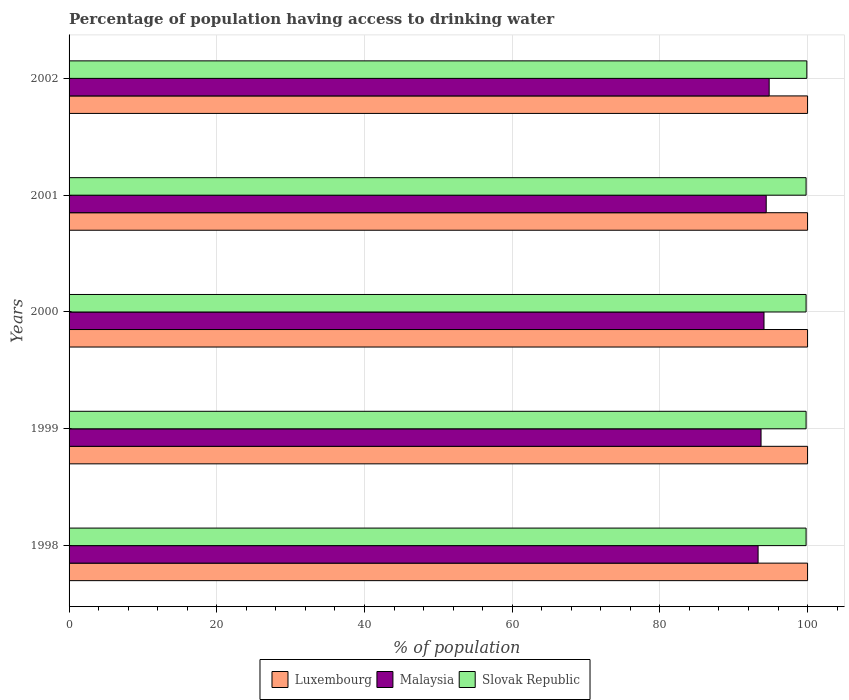How many different coloured bars are there?
Make the answer very short. 3. How many groups of bars are there?
Provide a succinct answer. 5. Are the number of bars on each tick of the Y-axis equal?
Keep it short and to the point. Yes. How many bars are there on the 3rd tick from the top?
Keep it short and to the point. 3. How many bars are there on the 3rd tick from the bottom?
Your response must be concise. 3. What is the label of the 2nd group of bars from the top?
Your answer should be very brief. 2001. In how many cases, is the number of bars for a given year not equal to the number of legend labels?
Your answer should be very brief. 0. What is the percentage of population having access to drinking water in Malaysia in 2001?
Provide a short and direct response. 94.4. Across all years, what is the maximum percentage of population having access to drinking water in Slovak Republic?
Ensure brevity in your answer.  99.9. Across all years, what is the minimum percentage of population having access to drinking water in Luxembourg?
Make the answer very short. 100. In which year was the percentage of population having access to drinking water in Luxembourg minimum?
Your answer should be very brief. 1998. What is the total percentage of population having access to drinking water in Malaysia in the graph?
Provide a succinct answer. 470.3. What is the difference between the percentage of population having access to drinking water in Malaysia in 1999 and that in 2001?
Give a very brief answer. -0.7. What is the difference between the percentage of population having access to drinking water in Luxembourg in 1998 and the percentage of population having access to drinking water in Malaysia in 2002?
Provide a short and direct response. 5.2. What is the average percentage of population having access to drinking water in Luxembourg per year?
Make the answer very short. 100. In the year 2001, what is the difference between the percentage of population having access to drinking water in Luxembourg and percentage of population having access to drinking water in Malaysia?
Offer a terse response. 5.6. In how many years, is the percentage of population having access to drinking water in Luxembourg greater than 48 %?
Keep it short and to the point. 5. What is the ratio of the percentage of population having access to drinking water in Malaysia in 2000 to that in 2001?
Keep it short and to the point. 1. Is the percentage of population having access to drinking water in Slovak Republic in 1999 less than that in 2000?
Provide a succinct answer. No. What is the difference between the highest and the second highest percentage of population having access to drinking water in Luxembourg?
Provide a succinct answer. 0. What is the difference between the highest and the lowest percentage of population having access to drinking water in Malaysia?
Offer a terse response. 1.5. In how many years, is the percentage of population having access to drinking water in Malaysia greater than the average percentage of population having access to drinking water in Malaysia taken over all years?
Keep it short and to the point. 3. Is the sum of the percentage of population having access to drinking water in Malaysia in 1999 and 2000 greater than the maximum percentage of population having access to drinking water in Slovak Republic across all years?
Your answer should be very brief. Yes. What does the 1st bar from the top in 2001 represents?
Give a very brief answer. Slovak Republic. What does the 3rd bar from the bottom in 2000 represents?
Provide a short and direct response. Slovak Republic. How many bars are there?
Give a very brief answer. 15. How many years are there in the graph?
Offer a terse response. 5. What is the difference between two consecutive major ticks on the X-axis?
Give a very brief answer. 20. Does the graph contain any zero values?
Your answer should be very brief. No. Does the graph contain grids?
Offer a terse response. Yes. How many legend labels are there?
Ensure brevity in your answer.  3. How are the legend labels stacked?
Ensure brevity in your answer.  Horizontal. What is the title of the graph?
Ensure brevity in your answer.  Percentage of population having access to drinking water. What is the label or title of the X-axis?
Give a very brief answer. % of population. What is the % of population of Malaysia in 1998?
Make the answer very short. 93.3. What is the % of population in Slovak Republic in 1998?
Keep it short and to the point. 99.8. What is the % of population of Luxembourg in 1999?
Your response must be concise. 100. What is the % of population of Malaysia in 1999?
Your response must be concise. 93.7. What is the % of population in Slovak Republic in 1999?
Provide a short and direct response. 99.8. What is the % of population of Luxembourg in 2000?
Offer a very short reply. 100. What is the % of population in Malaysia in 2000?
Make the answer very short. 94.1. What is the % of population of Slovak Republic in 2000?
Offer a very short reply. 99.8. What is the % of population in Luxembourg in 2001?
Make the answer very short. 100. What is the % of population of Malaysia in 2001?
Ensure brevity in your answer.  94.4. What is the % of population of Slovak Republic in 2001?
Give a very brief answer. 99.8. What is the % of population of Luxembourg in 2002?
Offer a very short reply. 100. What is the % of population of Malaysia in 2002?
Make the answer very short. 94.8. What is the % of population in Slovak Republic in 2002?
Provide a short and direct response. 99.9. Across all years, what is the maximum % of population in Malaysia?
Provide a short and direct response. 94.8. Across all years, what is the maximum % of population of Slovak Republic?
Ensure brevity in your answer.  99.9. Across all years, what is the minimum % of population of Luxembourg?
Your answer should be compact. 100. Across all years, what is the minimum % of population in Malaysia?
Provide a short and direct response. 93.3. Across all years, what is the minimum % of population in Slovak Republic?
Your response must be concise. 99.8. What is the total % of population of Luxembourg in the graph?
Your answer should be compact. 500. What is the total % of population of Malaysia in the graph?
Offer a very short reply. 470.3. What is the total % of population in Slovak Republic in the graph?
Keep it short and to the point. 499.1. What is the difference between the % of population of Luxembourg in 1998 and that in 1999?
Provide a short and direct response. 0. What is the difference between the % of population in Malaysia in 1998 and that in 1999?
Keep it short and to the point. -0.4. What is the difference between the % of population of Slovak Republic in 1998 and that in 1999?
Give a very brief answer. 0. What is the difference between the % of population in Luxembourg in 1999 and that in 2000?
Make the answer very short. 0. What is the difference between the % of population in Malaysia in 1999 and that in 2000?
Give a very brief answer. -0.4. What is the difference between the % of population of Slovak Republic in 1999 and that in 2000?
Your answer should be very brief. 0. What is the difference between the % of population of Luxembourg in 1999 and that in 2001?
Your answer should be compact. 0. What is the difference between the % of population in Malaysia in 1999 and that in 2002?
Offer a terse response. -1.1. What is the difference between the % of population of Luxembourg in 2000 and that in 2001?
Make the answer very short. 0. What is the difference between the % of population of Malaysia in 2000 and that in 2001?
Offer a very short reply. -0.3. What is the difference between the % of population in Slovak Republic in 2000 and that in 2001?
Offer a very short reply. 0. What is the difference between the % of population of Luxembourg in 2000 and that in 2002?
Your answer should be compact. 0. What is the difference between the % of population in Slovak Republic in 2000 and that in 2002?
Offer a very short reply. -0.1. What is the difference between the % of population in Luxembourg in 2001 and that in 2002?
Your answer should be very brief. 0. What is the difference between the % of population of Slovak Republic in 2001 and that in 2002?
Give a very brief answer. -0.1. What is the difference between the % of population in Luxembourg in 1998 and the % of population in Malaysia in 1999?
Your answer should be compact. 6.3. What is the difference between the % of population in Luxembourg in 1998 and the % of population in Slovak Republic in 1999?
Keep it short and to the point. 0.2. What is the difference between the % of population of Luxembourg in 1998 and the % of population of Slovak Republic in 2001?
Keep it short and to the point. 0.2. What is the difference between the % of population of Malaysia in 1998 and the % of population of Slovak Republic in 2001?
Your answer should be compact. -6.5. What is the difference between the % of population of Luxembourg in 1999 and the % of population of Malaysia in 2000?
Your response must be concise. 5.9. What is the difference between the % of population in Malaysia in 1999 and the % of population in Slovak Republic in 2000?
Provide a short and direct response. -6.1. What is the difference between the % of population in Luxembourg in 1999 and the % of population in Slovak Republic in 2001?
Ensure brevity in your answer.  0.2. What is the difference between the % of population of Luxembourg in 1999 and the % of population of Slovak Republic in 2002?
Provide a short and direct response. 0.1. What is the difference between the % of population in Luxembourg in 2000 and the % of population in Malaysia in 2001?
Your answer should be compact. 5.6. What is the difference between the % of population of Luxembourg in 2000 and the % of population of Malaysia in 2002?
Make the answer very short. 5.2. What is the difference between the % of population in Luxembourg in 2000 and the % of population in Slovak Republic in 2002?
Give a very brief answer. 0.1. What is the difference between the % of population in Malaysia in 2000 and the % of population in Slovak Republic in 2002?
Offer a terse response. -5.8. What is the difference between the % of population in Luxembourg in 2001 and the % of population in Slovak Republic in 2002?
Provide a succinct answer. 0.1. What is the average % of population in Luxembourg per year?
Your response must be concise. 100. What is the average % of population in Malaysia per year?
Ensure brevity in your answer.  94.06. What is the average % of population of Slovak Republic per year?
Your response must be concise. 99.82. In the year 1998, what is the difference between the % of population of Luxembourg and % of population of Malaysia?
Make the answer very short. 6.7. In the year 1999, what is the difference between the % of population in Luxembourg and % of population in Malaysia?
Your answer should be compact. 6.3. In the year 1999, what is the difference between the % of population in Luxembourg and % of population in Slovak Republic?
Your answer should be very brief. 0.2. In the year 2000, what is the difference between the % of population in Luxembourg and % of population in Slovak Republic?
Provide a short and direct response. 0.2. In the year 2001, what is the difference between the % of population of Malaysia and % of population of Slovak Republic?
Your answer should be very brief. -5.4. In the year 2002, what is the difference between the % of population of Luxembourg and % of population of Malaysia?
Ensure brevity in your answer.  5.2. What is the ratio of the % of population of Luxembourg in 1998 to that in 1999?
Your answer should be very brief. 1. What is the ratio of the % of population in Luxembourg in 1998 to that in 2000?
Offer a terse response. 1. What is the ratio of the % of population in Malaysia in 1998 to that in 2000?
Offer a terse response. 0.99. What is the ratio of the % of population of Luxembourg in 1998 to that in 2001?
Ensure brevity in your answer.  1. What is the ratio of the % of population of Malaysia in 1998 to that in 2001?
Ensure brevity in your answer.  0.99. What is the ratio of the % of population of Malaysia in 1998 to that in 2002?
Give a very brief answer. 0.98. What is the ratio of the % of population of Luxembourg in 1999 to that in 2000?
Offer a terse response. 1. What is the ratio of the % of population in Malaysia in 1999 to that in 2000?
Make the answer very short. 1. What is the ratio of the % of population of Slovak Republic in 1999 to that in 2000?
Offer a terse response. 1. What is the ratio of the % of population of Luxembourg in 1999 to that in 2001?
Provide a short and direct response. 1. What is the ratio of the % of population in Slovak Republic in 1999 to that in 2001?
Give a very brief answer. 1. What is the ratio of the % of population in Malaysia in 1999 to that in 2002?
Your answer should be compact. 0.99. What is the ratio of the % of population in Slovak Republic in 1999 to that in 2002?
Your response must be concise. 1. What is the ratio of the % of population of Malaysia in 2000 to that in 2001?
Keep it short and to the point. 1. What is the ratio of the % of population of Malaysia in 2000 to that in 2002?
Your response must be concise. 0.99. What is the ratio of the % of population of Malaysia in 2001 to that in 2002?
Ensure brevity in your answer.  1. What is the difference between the highest and the second highest % of population in Luxembourg?
Your answer should be very brief. 0. What is the difference between the highest and the second highest % of population in Slovak Republic?
Offer a terse response. 0.1. What is the difference between the highest and the lowest % of population of Luxembourg?
Provide a short and direct response. 0. 